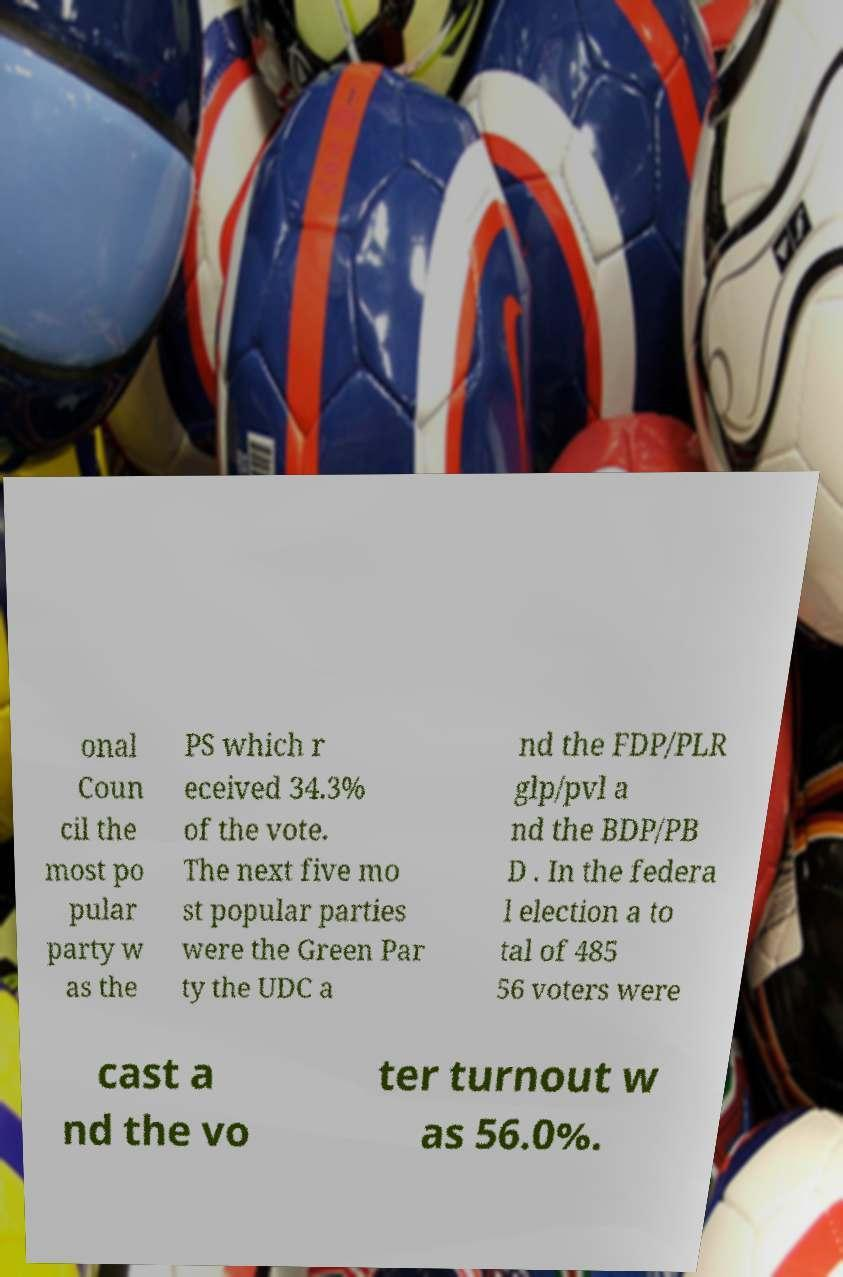What messages or text are displayed in this image? I need them in a readable, typed format. onal Coun cil the most po pular party w as the PS which r eceived 34.3% of the vote. The next five mo st popular parties were the Green Par ty the UDC a nd the FDP/PLR glp/pvl a nd the BDP/PB D . In the federa l election a to tal of 485 56 voters were cast a nd the vo ter turnout w as 56.0%. 